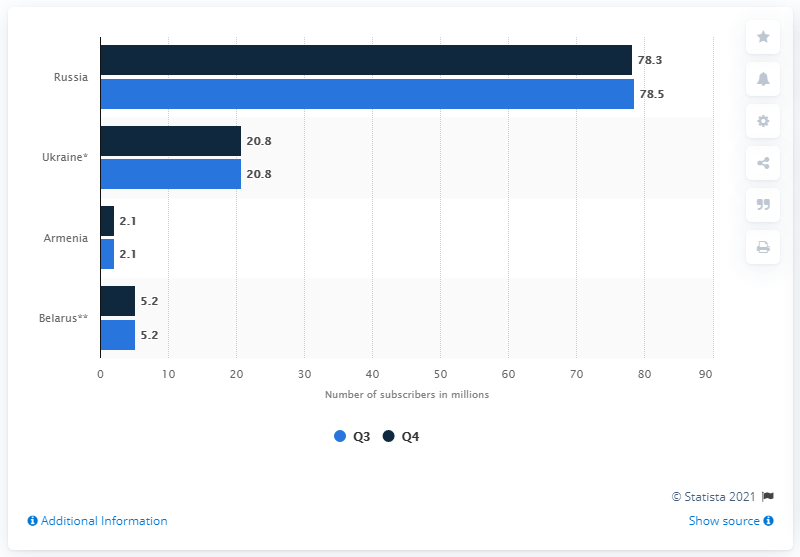Mention a couple of crucial points in this snapshot. In the fourth quarter of 2017, there were 78.5 mobile subscribers in Russia. 